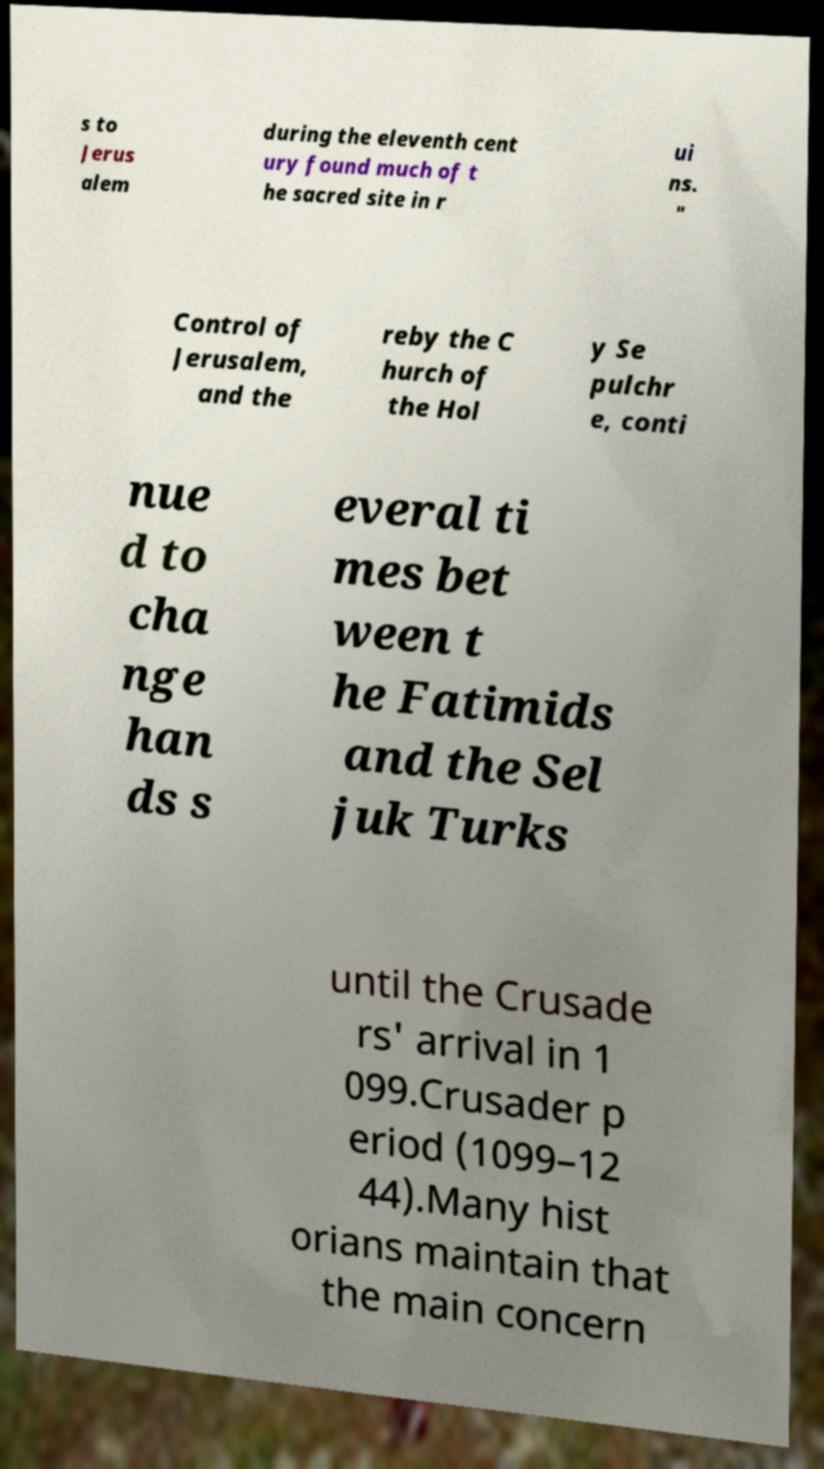There's text embedded in this image that I need extracted. Can you transcribe it verbatim? s to Jerus alem during the eleventh cent ury found much of t he sacred site in r ui ns. " Control of Jerusalem, and the reby the C hurch of the Hol y Se pulchr e, conti nue d to cha nge han ds s everal ti mes bet ween t he Fatimids and the Sel juk Turks until the Crusade rs' arrival in 1 099.Crusader p eriod (1099–12 44).Many hist orians maintain that the main concern 